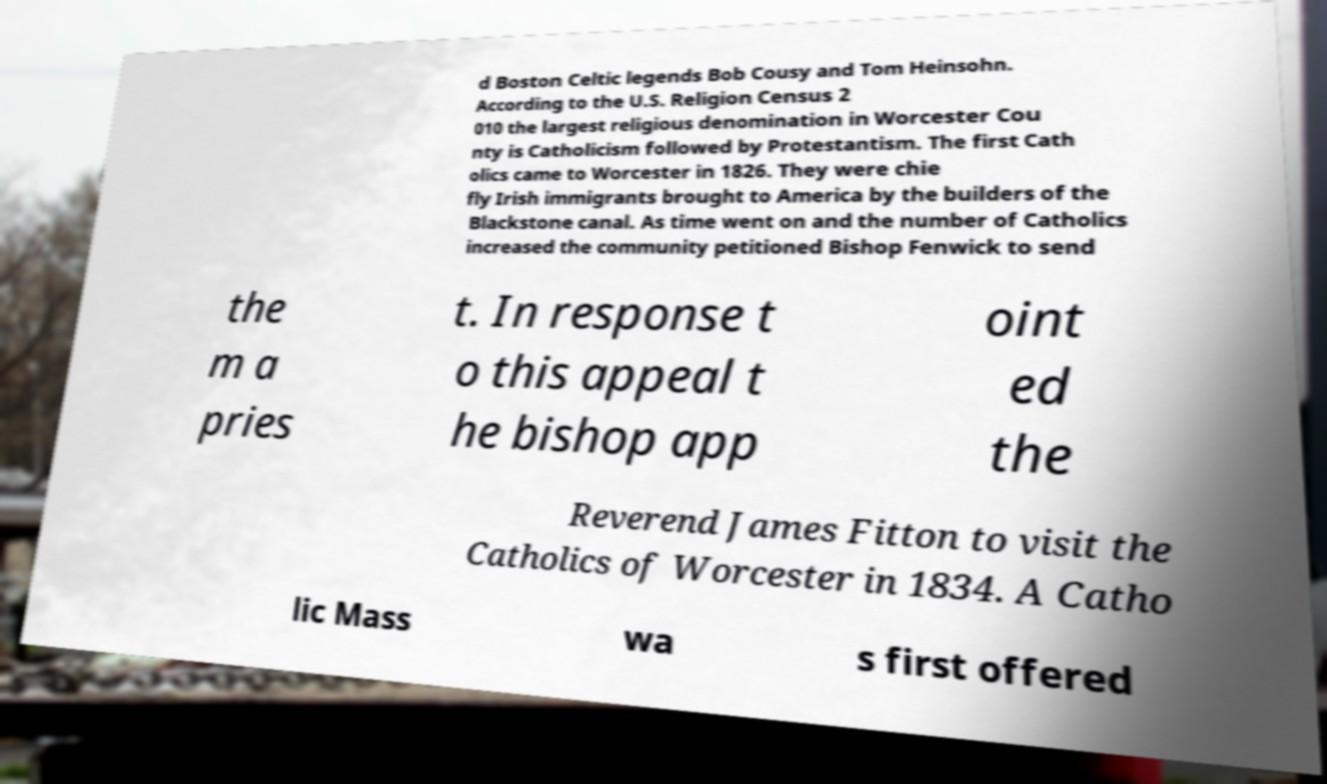For documentation purposes, I need the text within this image transcribed. Could you provide that? d Boston Celtic legends Bob Cousy and Tom Heinsohn. According to the U.S. Religion Census 2 010 the largest religious denomination in Worcester Cou nty is Catholicism followed by Protestantism. The first Cath olics came to Worcester in 1826. They were chie fly Irish immigrants brought to America by the builders of the Blackstone canal. As time went on and the number of Catholics increased the community petitioned Bishop Fenwick to send the m a pries t. In response t o this appeal t he bishop app oint ed the Reverend James Fitton to visit the Catholics of Worcester in 1834. A Catho lic Mass wa s first offered 